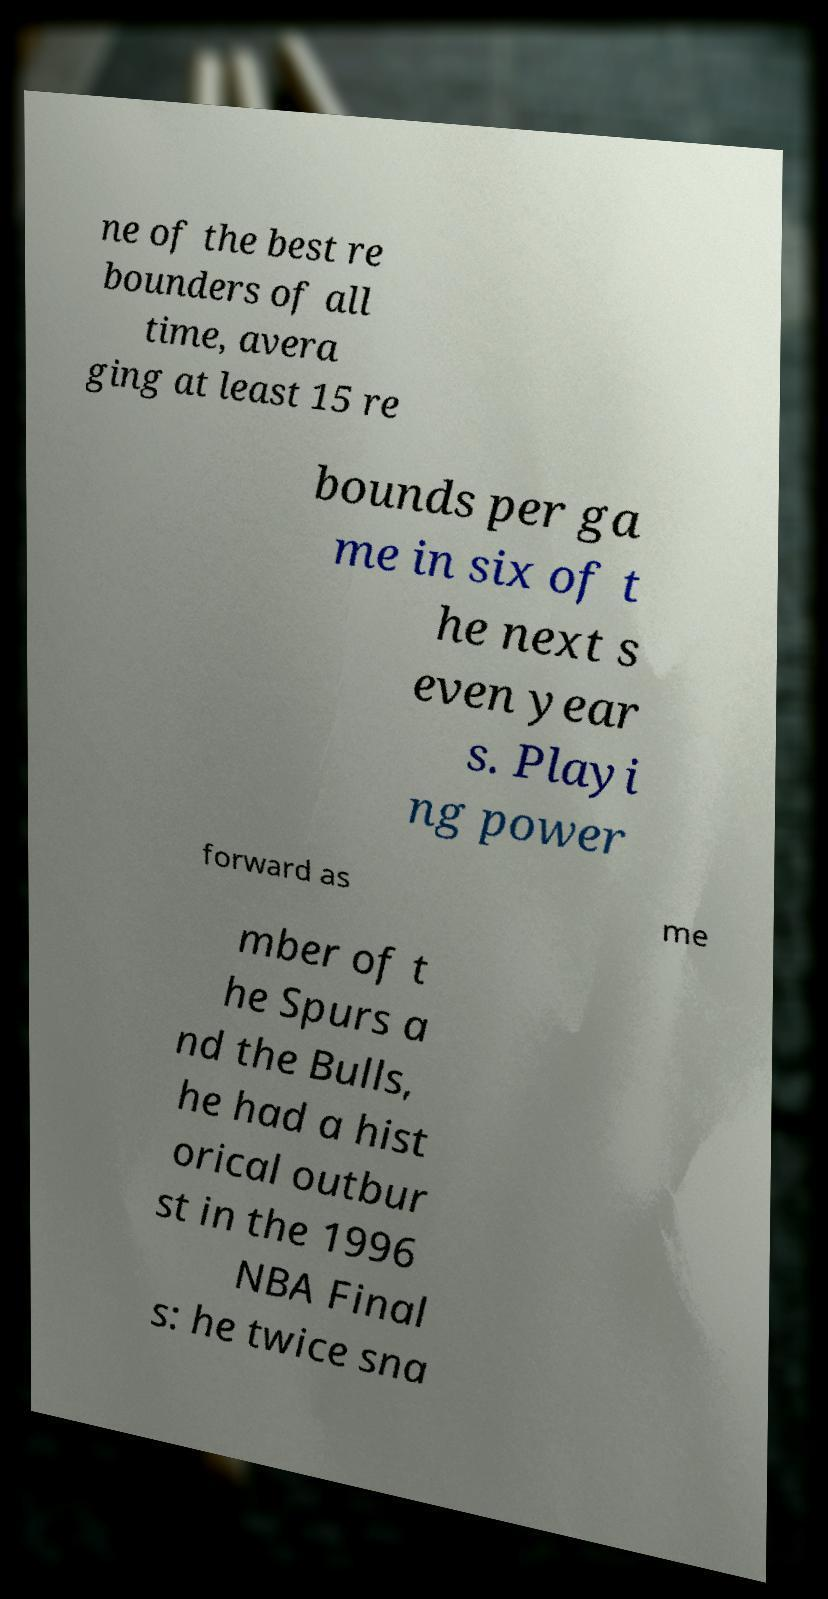Please identify and transcribe the text found in this image. ne of the best re bounders of all time, avera ging at least 15 re bounds per ga me in six of t he next s even year s. Playi ng power forward as me mber of t he Spurs a nd the Bulls, he had a hist orical outbur st in the 1996 NBA Final s: he twice sna 